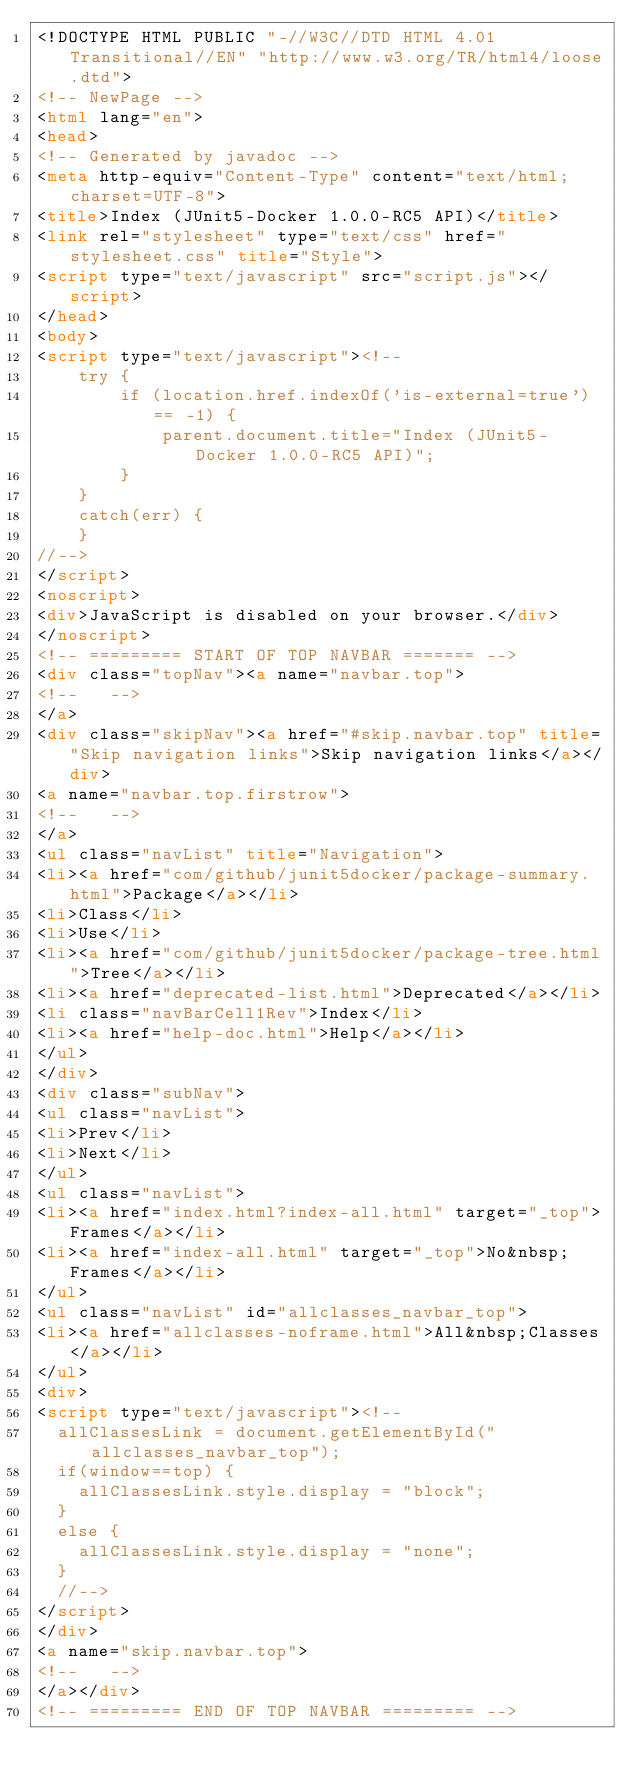<code> <loc_0><loc_0><loc_500><loc_500><_HTML_><!DOCTYPE HTML PUBLIC "-//W3C//DTD HTML 4.01 Transitional//EN" "http://www.w3.org/TR/html4/loose.dtd">
<!-- NewPage -->
<html lang="en">
<head>
<!-- Generated by javadoc -->
<meta http-equiv="Content-Type" content="text/html; charset=UTF-8">
<title>Index (JUnit5-Docker 1.0.0-RC5 API)</title>
<link rel="stylesheet" type="text/css" href="stylesheet.css" title="Style">
<script type="text/javascript" src="script.js"></script>
</head>
<body>
<script type="text/javascript"><!--
    try {
        if (location.href.indexOf('is-external=true') == -1) {
            parent.document.title="Index (JUnit5-Docker 1.0.0-RC5 API)";
        }
    }
    catch(err) {
    }
//-->
</script>
<noscript>
<div>JavaScript is disabled on your browser.</div>
</noscript>
<!-- ========= START OF TOP NAVBAR ======= -->
<div class="topNav"><a name="navbar.top">
<!--   -->
</a>
<div class="skipNav"><a href="#skip.navbar.top" title="Skip navigation links">Skip navigation links</a></div>
<a name="navbar.top.firstrow">
<!--   -->
</a>
<ul class="navList" title="Navigation">
<li><a href="com/github/junit5docker/package-summary.html">Package</a></li>
<li>Class</li>
<li>Use</li>
<li><a href="com/github/junit5docker/package-tree.html">Tree</a></li>
<li><a href="deprecated-list.html">Deprecated</a></li>
<li class="navBarCell1Rev">Index</li>
<li><a href="help-doc.html">Help</a></li>
</ul>
</div>
<div class="subNav">
<ul class="navList">
<li>Prev</li>
<li>Next</li>
</ul>
<ul class="navList">
<li><a href="index.html?index-all.html" target="_top">Frames</a></li>
<li><a href="index-all.html" target="_top">No&nbsp;Frames</a></li>
</ul>
<ul class="navList" id="allclasses_navbar_top">
<li><a href="allclasses-noframe.html">All&nbsp;Classes</a></li>
</ul>
<div>
<script type="text/javascript"><!--
  allClassesLink = document.getElementById("allclasses_navbar_top");
  if(window==top) {
    allClassesLink.style.display = "block";
  }
  else {
    allClassesLink.style.display = "none";
  }
  //-->
</script>
</div>
<a name="skip.navbar.top">
<!--   -->
</a></div>
<!-- ========= END OF TOP NAVBAR ========= --></code> 